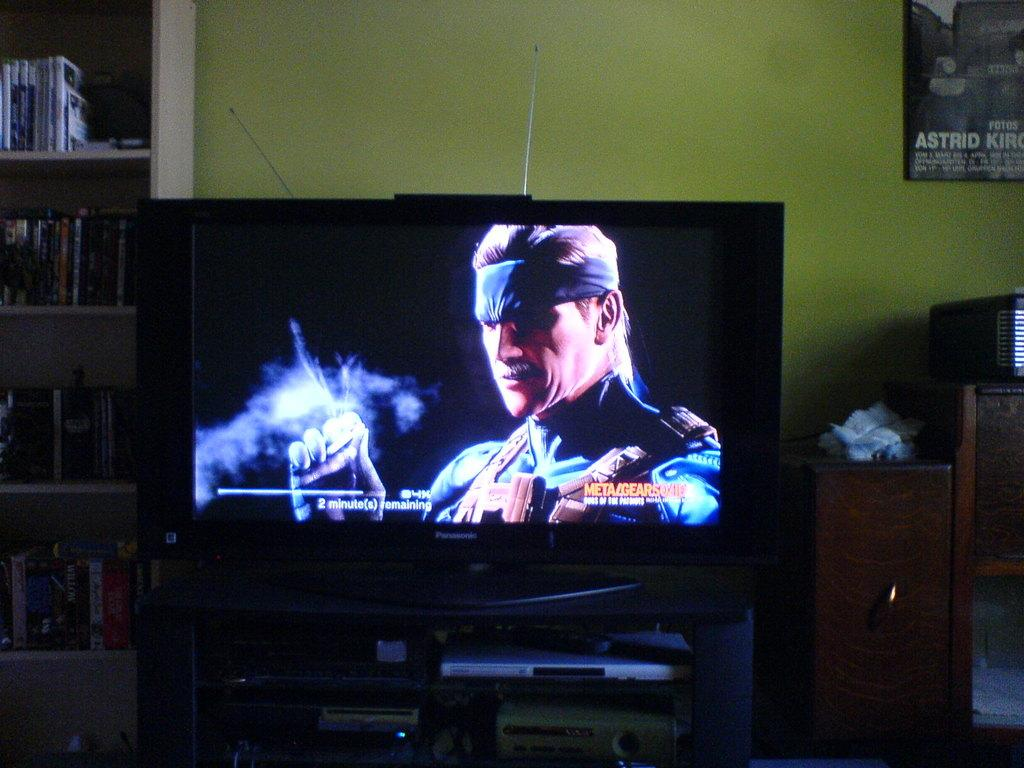<image>
Relay a brief, clear account of the picture shown. A poster on a green wall has the name Astrid on it. 